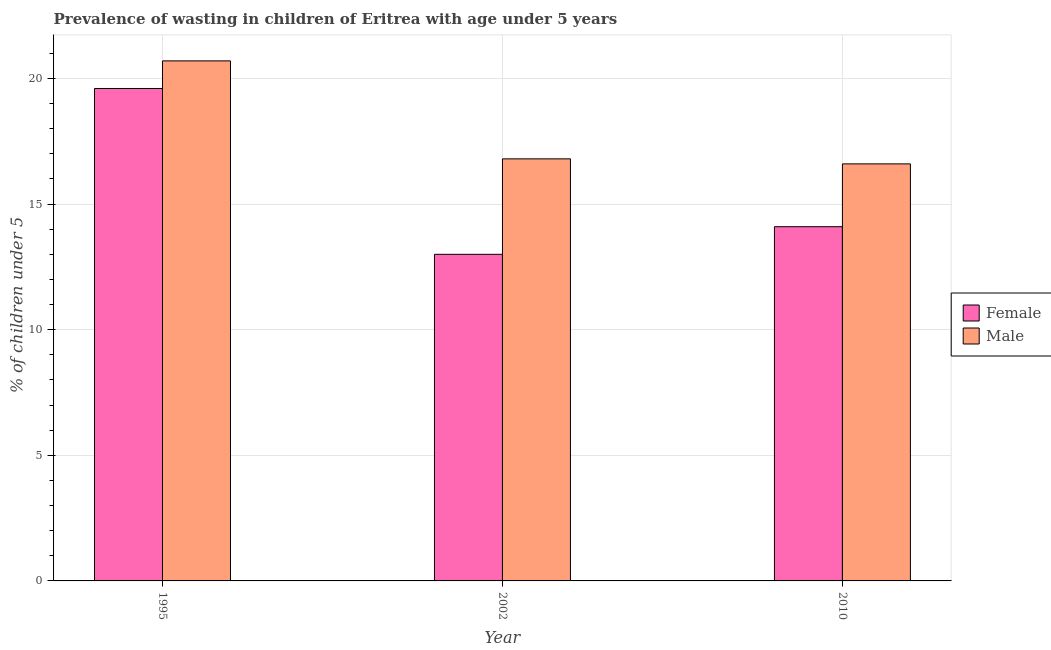How many groups of bars are there?
Provide a short and direct response. 3. Are the number of bars per tick equal to the number of legend labels?
Your answer should be very brief. Yes. What is the label of the 3rd group of bars from the left?
Your response must be concise. 2010. What is the percentage of undernourished female children in 1995?
Your answer should be very brief. 19.6. Across all years, what is the maximum percentage of undernourished male children?
Offer a terse response. 20.7. Across all years, what is the minimum percentage of undernourished male children?
Keep it short and to the point. 16.6. In which year was the percentage of undernourished female children maximum?
Keep it short and to the point. 1995. In which year was the percentage of undernourished male children minimum?
Keep it short and to the point. 2010. What is the total percentage of undernourished female children in the graph?
Make the answer very short. 46.7. What is the difference between the percentage of undernourished female children in 1995 and that in 2002?
Your answer should be compact. 6.6. What is the difference between the percentage of undernourished female children in 1995 and the percentage of undernourished male children in 2010?
Give a very brief answer. 5.5. What is the average percentage of undernourished female children per year?
Make the answer very short. 15.57. In the year 2010, what is the difference between the percentage of undernourished female children and percentage of undernourished male children?
Your answer should be compact. 0. In how many years, is the percentage of undernourished male children greater than 11 %?
Your response must be concise. 3. What is the ratio of the percentage of undernourished male children in 1995 to that in 2002?
Give a very brief answer. 1.23. Is the percentage of undernourished male children in 1995 less than that in 2002?
Your answer should be very brief. No. Is the difference between the percentage of undernourished female children in 2002 and 2010 greater than the difference between the percentage of undernourished male children in 2002 and 2010?
Provide a succinct answer. No. What is the difference between the highest and the second highest percentage of undernourished female children?
Your answer should be compact. 5.5. What is the difference between the highest and the lowest percentage of undernourished male children?
Offer a terse response. 4.1. In how many years, is the percentage of undernourished female children greater than the average percentage of undernourished female children taken over all years?
Keep it short and to the point. 1. What does the 2nd bar from the left in 2002 represents?
Your response must be concise. Male. What does the 1st bar from the right in 1995 represents?
Make the answer very short. Male. How many bars are there?
Provide a succinct answer. 6. What is the difference between two consecutive major ticks on the Y-axis?
Your answer should be very brief. 5. Does the graph contain any zero values?
Offer a terse response. No. Does the graph contain grids?
Provide a short and direct response. Yes. What is the title of the graph?
Keep it short and to the point. Prevalence of wasting in children of Eritrea with age under 5 years. What is the label or title of the Y-axis?
Provide a short and direct response.  % of children under 5. What is the  % of children under 5 of Female in 1995?
Your response must be concise. 19.6. What is the  % of children under 5 of Male in 1995?
Offer a terse response. 20.7. What is the  % of children under 5 in Female in 2002?
Offer a very short reply. 13. What is the  % of children under 5 of Male in 2002?
Give a very brief answer. 16.8. What is the  % of children under 5 in Female in 2010?
Provide a short and direct response. 14.1. What is the  % of children under 5 in Male in 2010?
Provide a short and direct response. 16.6. Across all years, what is the maximum  % of children under 5 of Female?
Your response must be concise. 19.6. Across all years, what is the maximum  % of children under 5 of Male?
Provide a short and direct response. 20.7. Across all years, what is the minimum  % of children under 5 in Female?
Your answer should be very brief. 13. Across all years, what is the minimum  % of children under 5 in Male?
Ensure brevity in your answer.  16.6. What is the total  % of children under 5 of Female in the graph?
Provide a short and direct response. 46.7. What is the total  % of children under 5 of Male in the graph?
Keep it short and to the point. 54.1. What is the difference between the  % of children under 5 in Female in 1995 and that in 2002?
Keep it short and to the point. 6.6. What is the difference between the  % of children under 5 of Female in 1995 and that in 2010?
Your answer should be very brief. 5.5. What is the difference between the  % of children under 5 of Male in 1995 and that in 2010?
Provide a short and direct response. 4.1. What is the difference between the  % of children under 5 of Female in 1995 and the  % of children under 5 of Male in 2002?
Provide a short and direct response. 2.8. What is the average  % of children under 5 of Female per year?
Ensure brevity in your answer.  15.57. What is the average  % of children under 5 in Male per year?
Give a very brief answer. 18.03. In the year 2002, what is the difference between the  % of children under 5 of Female and  % of children under 5 of Male?
Give a very brief answer. -3.8. What is the ratio of the  % of children under 5 of Female in 1995 to that in 2002?
Keep it short and to the point. 1.51. What is the ratio of the  % of children under 5 in Male in 1995 to that in 2002?
Ensure brevity in your answer.  1.23. What is the ratio of the  % of children under 5 in Female in 1995 to that in 2010?
Offer a very short reply. 1.39. What is the ratio of the  % of children under 5 of Male in 1995 to that in 2010?
Your answer should be very brief. 1.25. What is the ratio of the  % of children under 5 of Female in 2002 to that in 2010?
Offer a very short reply. 0.92. What is the ratio of the  % of children under 5 in Male in 2002 to that in 2010?
Keep it short and to the point. 1.01. What is the difference between the highest and the second highest  % of children under 5 of Male?
Offer a very short reply. 3.9. What is the difference between the highest and the lowest  % of children under 5 of Male?
Ensure brevity in your answer.  4.1. 